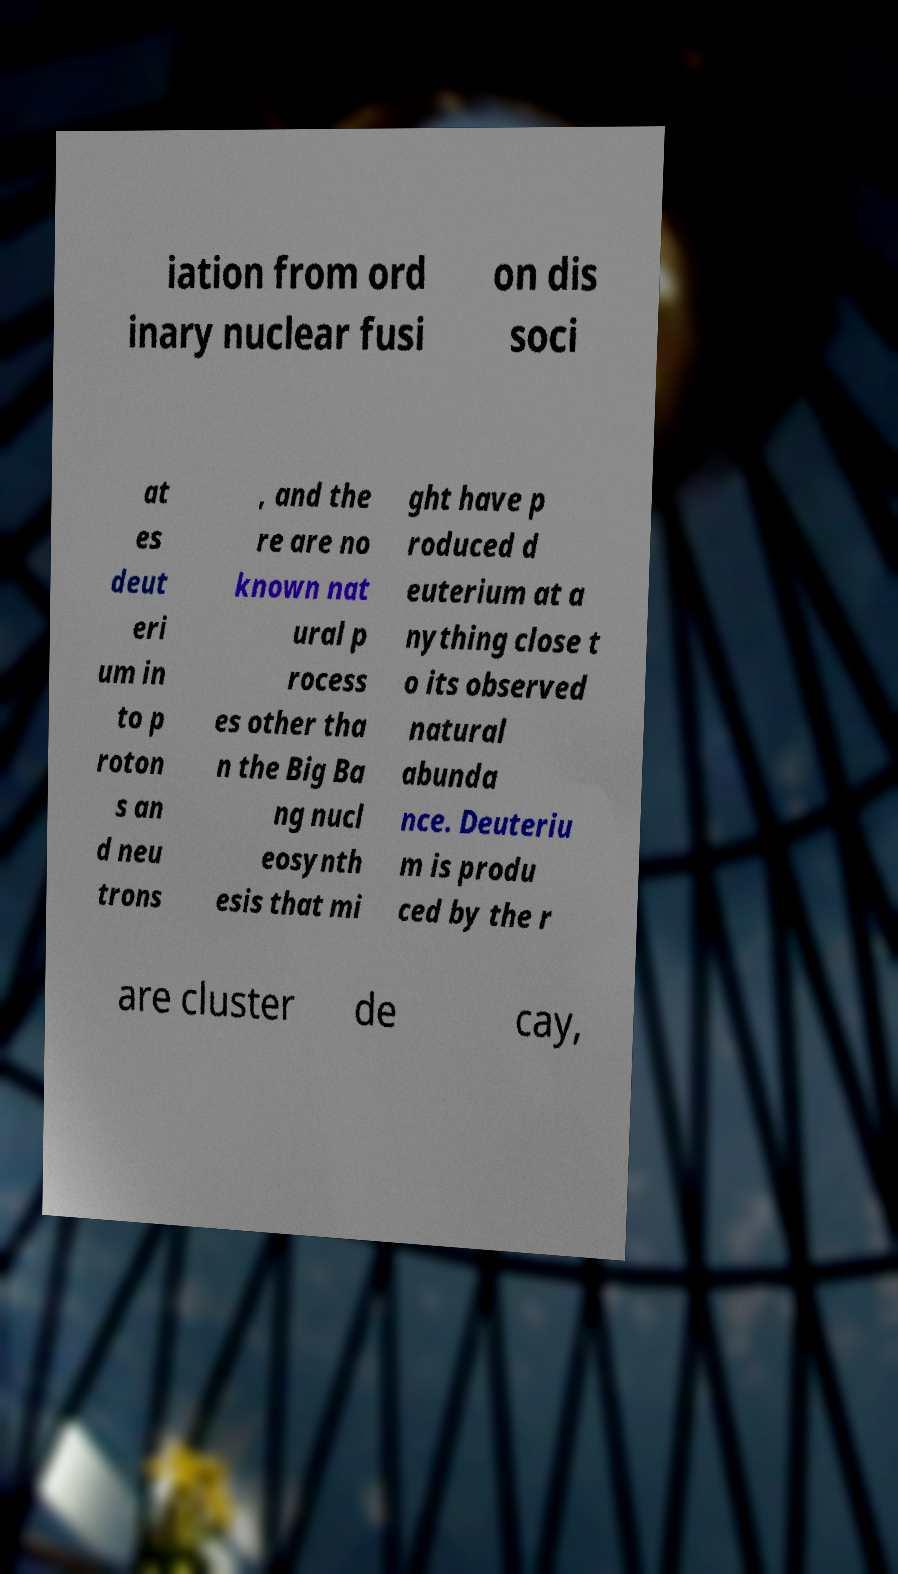I need the written content from this picture converted into text. Can you do that? iation from ord inary nuclear fusi on dis soci at es deut eri um in to p roton s an d neu trons , and the re are no known nat ural p rocess es other tha n the Big Ba ng nucl eosynth esis that mi ght have p roduced d euterium at a nything close t o its observed natural abunda nce. Deuteriu m is produ ced by the r are cluster de cay, 